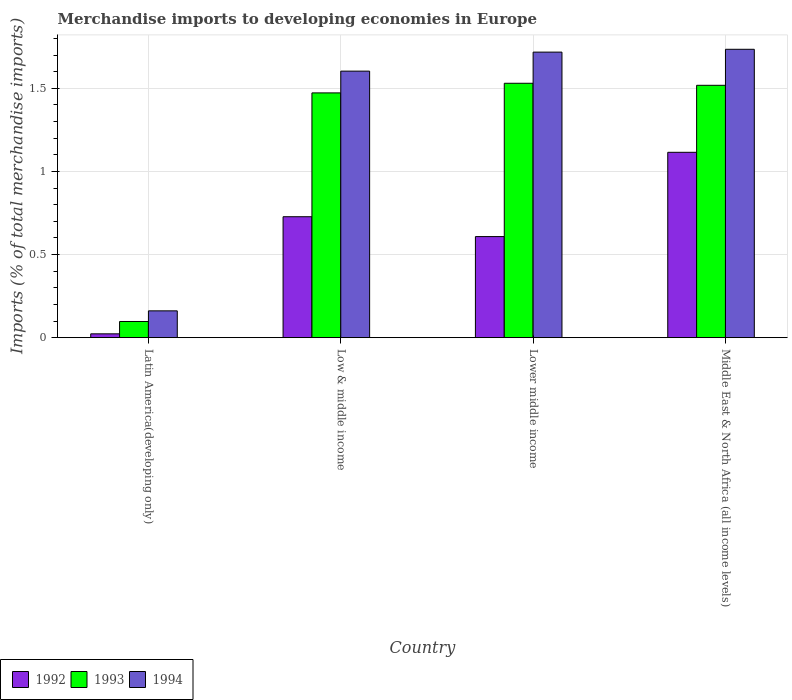How many groups of bars are there?
Provide a succinct answer. 4. How many bars are there on the 2nd tick from the left?
Your answer should be very brief. 3. What is the label of the 3rd group of bars from the left?
Your response must be concise. Lower middle income. What is the percentage total merchandise imports in 1994 in Latin America(developing only)?
Provide a short and direct response. 0.16. Across all countries, what is the maximum percentage total merchandise imports in 1993?
Offer a very short reply. 1.53. Across all countries, what is the minimum percentage total merchandise imports in 1992?
Provide a short and direct response. 0.02. In which country was the percentage total merchandise imports in 1993 maximum?
Your response must be concise. Lower middle income. In which country was the percentage total merchandise imports in 1994 minimum?
Provide a short and direct response. Latin America(developing only). What is the total percentage total merchandise imports in 1994 in the graph?
Offer a terse response. 5.22. What is the difference between the percentage total merchandise imports in 1993 in Latin America(developing only) and that in Lower middle income?
Make the answer very short. -1.43. What is the difference between the percentage total merchandise imports in 1994 in Middle East & North Africa (all income levels) and the percentage total merchandise imports in 1992 in Lower middle income?
Offer a very short reply. 1.13. What is the average percentage total merchandise imports in 1993 per country?
Ensure brevity in your answer.  1.15. What is the difference between the percentage total merchandise imports of/in 1992 and percentage total merchandise imports of/in 1994 in Middle East & North Africa (all income levels)?
Ensure brevity in your answer.  -0.62. In how many countries, is the percentage total merchandise imports in 1992 greater than 1.4 %?
Your answer should be compact. 0. What is the ratio of the percentage total merchandise imports in 1993 in Latin America(developing only) to that in Middle East & North Africa (all income levels)?
Give a very brief answer. 0.06. Is the percentage total merchandise imports in 1992 in Lower middle income less than that in Middle East & North Africa (all income levels)?
Offer a very short reply. Yes. Is the difference between the percentage total merchandise imports in 1992 in Latin America(developing only) and Middle East & North Africa (all income levels) greater than the difference between the percentage total merchandise imports in 1994 in Latin America(developing only) and Middle East & North Africa (all income levels)?
Provide a short and direct response. Yes. What is the difference between the highest and the second highest percentage total merchandise imports in 1993?
Offer a terse response. 0.01. What is the difference between the highest and the lowest percentage total merchandise imports in 1992?
Make the answer very short. 1.09. What does the 3rd bar from the left in Middle East & North Africa (all income levels) represents?
Offer a terse response. 1994. Is it the case that in every country, the sum of the percentage total merchandise imports in 1994 and percentage total merchandise imports in 1993 is greater than the percentage total merchandise imports in 1992?
Give a very brief answer. Yes. What is the difference between two consecutive major ticks on the Y-axis?
Your answer should be compact. 0.5. Does the graph contain grids?
Make the answer very short. Yes. How many legend labels are there?
Make the answer very short. 3. What is the title of the graph?
Offer a very short reply. Merchandise imports to developing economies in Europe. What is the label or title of the Y-axis?
Keep it short and to the point. Imports (% of total merchandise imports). What is the Imports (% of total merchandise imports) in 1992 in Latin America(developing only)?
Your response must be concise. 0.02. What is the Imports (% of total merchandise imports) of 1993 in Latin America(developing only)?
Provide a succinct answer. 0.1. What is the Imports (% of total merchandise imports) of 1994 in Latin America(developing only)?
Your response must be concise. 0.16. What is the Imports (% of total merchandise imports) of 1992 in Low & middle income?
Ensure brevity in your answer.  0.73. What is the Imports (% of total merchandise imports) of 1993 in Low & middle income?
Your answer should be compact. 1.47. What is the Imports (% of total merchandise imports) in 1994 in Low & middle income?
Give a very brief answer. 1.6. What is the Imports (% of total merchandise imports) in 1992 in Lower middle income?
Your response must be concise. 0.61. What is the Imports (% of total merchandise imports) of 1993 in Lower middle income?
Your answer should be compact. 1.53. What is the Imports (% of total merchandise imports) in 1994 in Lower middle income?
Make the answer very short. 1.72. What is the Imports (% of total merchandise imports) in 1992 in Middle East & North Africa (all income levels)?
Keep it short and to the point. 1.12. What is the Imports (% of total merchandise imports) in 1993 in Middle East & North Africa (all income levels)?
Offer a very short reply. 1.52. What is the Imports (% of total merchandise imports) in 1994 in Middle East & North Africa (all income levels)?
Keep it short and to the point. 1.74. Across all countries, what is the maximum Imports (% of total merchandise imports) of 1992?
Offer a very short reply. 1.12. Across all countries, what is the maximum Imports (% of total merchandise imports) of 1993?
Your answer should be very brief. 1.53. Across all countries, what is the maximum Imports (% of total merchandise imports) in 1994?
Keep it short and to the point. 1.74. Across all countries, what is the minimum Imports (% of total merchandise imports) of 1992?
Make the answer very short. 0.02. Across all countries, what is the minimum Imports (% of total merchandise imports) in 1993?
Make the answer very short. 0.1. Across all countries, what is the minimum Imports (% of total merchandise imports) in 1994?
Your response must be concise. 0.16. What is the total Imports (% of total merchandise imports) of 1992 in the graph?
Ensure brevity in your answer.  2.47. What is the total Imports (% of total merchandise imports) in 1993 in the graph?
Your response must be concise. 4.62. What is the total Imports (% of total merchandise imports) of 1994 in the graph?
Your answer should be compact. 5.22. What is the difference between the Imports (% of total merchandise imports) in 1992 in Latin America(developing only) and that in Low & middle income?
Give a very brief answer. -0.7. What is the difference between the Imports (% of total merchandise imports) of 1993 in Latin America(developing only) and that in Low & middle income?
Keep it short and to the point. -1.38. What is the difference between the Imports (% of total merchandise imports) of 1994 in Latin America(developing only) and that in Low & middle income?
Your answer should be compact. -1.44. What is the difference between the Imports (% of total merchandise imports) in 1992 in Latin America(developing only) and that in Lower middle income?
Give a very brief answer. -0.59. What is the difference between the Imports (% of total merchandise imports) in 1993 in Latin America(developing only) and that in Lower middle income?
Offer a very short reply. -1.43. What is the difference between the Imports (% of total merchandise imports) of 1994 in Latin America(developing only) and that in Lower middle income?
Give a very brief answer. -1.56. What is the difference between the Imports (% of total merchandise imports) in 1992 in Latin America(developing only) and that in Middle East & North Africa (all income levels)?
Your answer should be very brief. -1.09. What is the difference between the Imports (% of total merchandise imports) of 1993 in Latin America(developing only) and that in Middle East & North Africa (all income levels)?
Your answer should be very brief. -1.42. What is the difference between the Imports (% of total merchandise imports) of 1994 in Latin America(developing only) and that in Middle East & North Africa (all income levels)?
Offer a very short reply. -1.57. What is the difference between the Imports (% of total merchandise imports) in 1992 in Low & middle income and that in Lower middle income?
Give a very brief answer. 0.12. What is the difference between the Imports (% of total merchandise imports) in 1993 in Low & middle income and that in Lower middle income?
Provide a short and direct response. -0.06. What is the difference between the Imports (% of total merchandise imports) of 1994 in Low & middle income and that in Lower middle income?
Give a very brief answer. -0.11. What is the difference between the Imports (% of total merchandise imports) in 1992 in Low & middle income and that in Middle East & North Africa (all income levels)?
Offer a terse response. -0.39. What is the difference between the Imports (% of total merchandise imports) in 1993 in Low & middle income and that in Middle East & North Africa (all income levels)?
Provide a short and direct response. -0.05. What is the difference between the Imports (% of total merchandise imports) of 1994 in Low & middle income and that in Middle East & North Africa (all income levels)?
Make the answer very short. -0.13. What is the difference between the Imports (% of total merchandise imports) in 1992 in Lower middle income and that in Middle East & North Africa (all income levels)?
Your answer should be compact. -0.51. What is the difference between the Imports (% of total merchandise imports) in 1993 in Lower middle income and that in Middle East & North Africa (all income levels)?
Keep it short and to the point. 0.01. What is the difference between the Imports (% of total merchandise imports) of 1994 in Lower middle income and that in Middle East & North Africa (all income levels)?
Offer a terse response. -0.02. What is the difference between the Imports (% of total merchandise imports) of 1992 in Latin America(developing only) and the Imports (% of total merchandise imports) of 1993 in Low & middle income?
Give a very brief answer. -1.45. What is the difference between the Imports (% of total merchandise imports) of 1992 in Latin America(developing only) and the Imports (% of total merchandise imports) of 1994 in Low & middle income?
Make the answer very short. -1.58. What is the difference between the Imports (% of total merchandise imports) in 1993 in Latin America(developing only) and the Imports (% of total merchandise imports) in 1994 in Low & middle income?
Your answer should be very brief. -1.51. What is the difference between the Imports (% of total merchandise imports) of 1992 in Latin America(developing only) and the Imports (% of total merchandise imports) of 1993 in Lower middle income?
Provide a succinct answer. -1.51. What is the difference between the Imports (% of total merchandise imports) in 1992 in Latin America(developing only) and the Imports (% of total merchandise imports) in 1994 in Lower middle income?
Give a very brief answer. -1.7. What is the difference between the Imports (% of total merchandise imports) in 1993 in Latin America(developing only) and the Imports (% of total merchandise imports) in 1994 in Lower middle income?
Offer a very short reply. -1.62. What is the difference between the Imports (% of total merchandise imports) of 1992 in Latin America(developing only) and the Imports (% of total merchandise imports) of 1993 in Middle East & North Africa (all income levels)?
Offer a terse response. -1.5. What is the difference between the Imports (% of total merchandise imports) in 1992 in Latin America(developing only) and the Imports (% of total merchandise imports) in 1994 in Middle East & North Africa (all income levels)?
Provide a short and direct response. -1.71. What is the difference between the Imports (% of total merchandise imports) in 1993 in Latin America(developing only) and the Imports (% of total merchandise imports) in 1994 in Middle East & North Africa (all income levels)?
Your answer should be compact. -1.64. What is the difference between the Imports (% of total merchandise imports) of 1992 in Low & middle income and the Imports (% of total merchandise imports) of 1993 in Lower middle income?
Offer a terse response. -0.8. What is the difference between the Imports (% of total merchandise imports) of 1992 in Low & middle income and the Imports (% of total merchandise imports) of 1994 in Lower middle income?
Your answer should be very brief. -0.99. What is the difference between the Imports (% of total merchandise imports) in 1993 in Low & middle income and the Imports (% of total merchandise imports) in 1994 in Lower middle income?
Your response must be concise. -0.25. What is the difference between the Imports (% of total merchandise imports) of 1992 in Low & middle income and the Imports (% of total merchandise imports) of 1993 in Middle East & North Africa (all income levels)?
Keep it short and to the point. -0.79. What is the difference between the Imports (% of total merchandise imports) of 1992 in Low & middle income and the Imports (% of total merchandise imports) of 1994 in Middle East & North Africa (all income levels)?
Your response must be concise. -1.01. What is the difference between the Imports (% of total merchandise imports) in 1993 in Low & middle income and the Imports (% of total merchandise imports) in 1994 in Middle East & North Africa (all income levels)?
Make the answer very short. -0.26. What is the difference between the Imports (% of total merchandise imports) in 1992 in Lower middle income and the Imports (% of total merchandise imports) in 1993 in Middle East & North Africa (all income levels)?
Make the answer very short. -0.91. What is the difference between the Imports (% of total merchandise imports) in 1992 in Lower middle income and the Imports (% of total merchandise imports) in 1994 in Middle East & North Africa (all income levels)?
Make the answer very short. -1.13. What is the difference between the Imports (% of total merchandise imports) in 1993 in Lower middle income and the Imports (% of total merchandise imports) in 1994 in Middle East & North Africa (all income levels)?
Provide a succinct answer. -0.2. What is the average Imports (% of total merchandise imports) of 1992 per country?
Provide a succinct answer. 0.62. What is the average Imports (% of total merchandise imports) of 1993 per country?
Make the answer very short. 1.15. What is the average Imports (% of total merchandise imports) in 1994 per country?
Provide a succinct answer. 1.3. What is the difference between the Imports (% of total merchandise imports) in 1992 and Imports (% of total merchandise imports) in 1993 in Latin America(developing only)?
Your response must be concise. -0.07. What is the difference between the Imports (% of total merchandise imports) in 1992 and Imports (% of total merchandise imports) in 1994 in Latin America(developing only)?
Provide a short and direct response. -0.14. What is the difference between the Imports (% of total merchandise imports) in 1993 and Imports (% of total merchandise imports) in 1994 in Latin America(developing only)?
Ensure brevity in your answer.  -0.06. What is the difference between the Imports (% of total merchandise imports) in 1992 and Imports (% of total merchandise imports) in 1993 in Low & middle income?
Keep it short and to the point. -0.74. What is the difference between the Imports (% of total merchandise imports) in 1992 and Imports (% of total merchandise imports) in 1994 in Low & middle income?
Your response must be concise. -0.88. What is the difference between the Imports (% of total merchandise imports) in 1993 and Imports (% of total merchandise imports) in 1994 in Low & middle income?
Ensure brevity in your answer.  -0.13. What is the difference between the Imports (% of total merchandise imports) of 1992 and Imports (% of total merchandise imports) of 1993 in Lower middle income?
Your response must be concise. -0.92. What is the difference between the Imports (% of total merchandise imports) of 1992 and Imports (% of total merchandise imports) of 1994 in Lower middle income?
Offer a very short reply. -1.11. What is the difference between the Imports (% of total merchandise imports) of 1993 and Imports (% of total merchandise imports) of 1994 in Lower middle income?
Make the answer very short. -0.19. What is the difference between the Imports (% of total merchandise imports) in 1992 and Imports (% of total merchandise imports) in 1993 in Middle East & North Africa (all income levels)?
Give a very brief answer. -0.4. What is the difference between the Imports (% of total merchandise imports) of 1992 and Imports (% of total merchandise imports) of 1994 in Middle East & North Africa (all income levels)?
Ensure brevity in your answer.  -0.62. What is the difference between the Imports (% of total merchandise imports) of 1993 and Imports (% of total merchandise imports) of 1994 in Middle East & North Africa (all income levels)?
Ensure brevity in your answer.  -0.22. What is the ratio of the Imports (% of total merchandise imports) of 1992 in Latin America(developing only) to that in Low & middle income?
Make the answer very short. 0.03. What is the ratio of the Imports (% of total merchandise imports) in 1993 in Latin America(developing only) to that in Low & middle income?
Your response must be concise. 0.07. What is the ratio of the Imports (% of total merchandise imports) of 1994 in Latin America(developing only) to that in Low & middle income?
Ensure brevity in your answer.  0.1. What is the ratio of the Imports (% of total merchandise imports) of 1992 in Latin America(developing only) to that in Lower middle income?
Provide a succinct answer. 0.04. What is the ratio of the Imports (% of total merchandise imports) of 1993 in Latin America(developing only) to that in Lower middle income?
Your response must be concise. 0.06. What is the ratio of the Imports (% of total merchandise imports) in 1994 in Latin America(developing only) to that in Lower middle income?
Keep it short and to the point. 0.09. What is the ratio of the Imports (% of total merchandise imports) in 1992 in Latin America(developing only) to that in Middle East & North Africa (all income levels)?
Offer a very short reply. 0.02. What is the ratio of the Imports (% of total merchandise imports) in 1993 in Latin America(developing only) to that in Middle East & North Africa (all income levels)?
Provide a short and direct response. 0.06. What is the ratio of the Imports (% of total merchandise imports) of 1994 in Latin America(developing only) to that in Middle East & North Africa (all income levels)?
Your response must be concise. 0.09. What is the ratio of the Imports (% of total merchandise imports) in 1992 in Low & middle income to that in Lower middle income?
Provide a succinct answer. 1.2. What is the ratio of the Imports (% of total merchandise imports) of 1993 in Low & middle income to that in Lower middle income?
Keep it short and to the point. 0.96. What is the ratio of the Imports (% of total merchandise imports) of 1994 in Low & middle income to that in Lower middle income?
Ensure brevity in your answer.  0.93. What is the ratio of the Imports (% of total merchandise imports) in 1992 in Low & middle income to that in Middle East & North Africa (all income levels)?
Give a very brief answer. 0.65. What is the ratio of the Imports (% of total merchandise imports) in 1993 in Low & middle income to that in Middle East & North Africa (all income levels)?
Provide a short and direct response. 0.97. What is the ratio of the Imports (% of total merchandise imports) in 1994 in Low & middle income to that in Middle East & North Africa (all income levels)?
Provide a short and direct response. 0.92. What is the ratio of the Imports (% of total merchandise imports) in 1992 in Lower middle income to that in Middle East & North Africa (all income levels)?
Your answer should be compact. 0.55. What is the ratio of the Imports (% of total merchandise imports) in 1994 in Lower middle income to that in Middle East & North Africa (all income levels)?
Provide a succinct answer. 0.99. What is the difference between the highest and the second highest Imports (% of total merchandise imports) of 1992?
Provide a short and direct response. 0.39. What is the difference between the highest and the second highest Imports (% of total merchandise imports) in 1993?
Give a very brief answer. 0.01. What is the difference between the highest and the second highest Imports (% of total merchandise imports) in 1994?
Make the answer very short. 0.02. What is the difference between the highest and the lowest Imports (% of total merchandise imports) of 1992?
Provide a succinct answer. 1.09. What is the difference between the highest and the lowest Imports (% of total merchandise imports) in 1993?
Ensure brevity in your answer.  1.43. What is the difference between the highest and the lowest Imports (% of total merchandise imports) of 1994?
Ensure brevity in your answer.  1.57. 